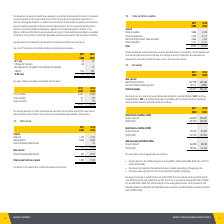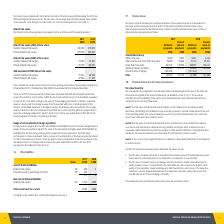According to National Storage Reit's financial document, What is the range of maturity dates on the facilities in 2018? 23 July 2019 to 23 December 2026. The document states: "ange from 23 July 2020 to 23 December 2026 (2018: 23 July 2019 to 23 December 2026). • The interest rate applied is the bank bill rate plus a margin d..." Also, What is the drawn amount from bank finance facilities (AUD) in 2019? According to the financial document, 663,800 (in thousands). The relevant text states: "Drawn amount 663,800 520,300..." Also, What is the drawn amount from bank finance facilities (AUD) in 2018? According to the financial document, 520,300 (in thousands). The relevant text states: "Drawn amount 663,800 520,300..." Also, can you calculate: What is the change in Bank finance facilities (AUD) Drawn amount from 2018 to 2019? Based on the calculation: 663,800-520,300, the result is 143500 (in thousands). This is based on the information: "Drawn amount 663,800 520,300 Drawn amount 663,800 520,300..." The key data points involved are: 520,300, 663,800. Also, can you calculate: What is the change in Bank finance facilities (AUD) Facility limit from 2018 to 2019? Based on the calculation: 680,000-605,000, the result is 75000 (in thousands). This is based on the information: "Facility limit 680,000 605,000 Facility limit 680,000 605,000..." The key data points involved are: 605,000, 680,000. Also, can you calculate: What is the change in Bank finance facilities (NZD) Drawn amount from 2018 to 2019? Based on the calculation: 192,250-87,500, the result is 104750 (in thousands). This is based on the information: "Drawn amount 192,250 87,500 Drawn amount 192,250 87,500..." The key data points involved are: 192,250, 87,500. 